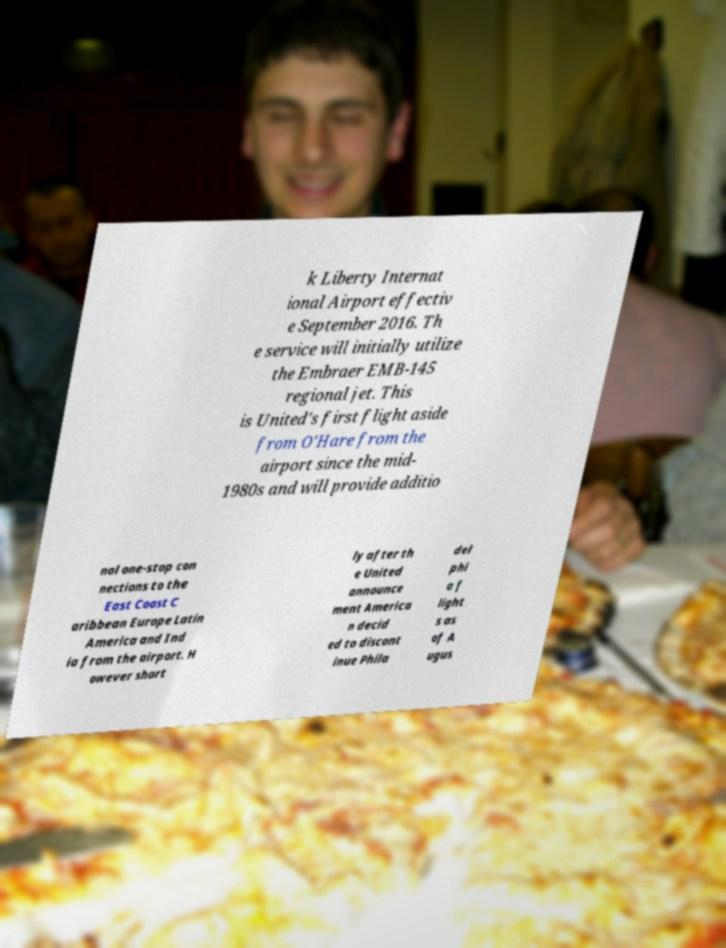Could you extract and type out the text from this image? k Liberty Internat ional Airport effectiv e September 2016. Th e service will initially utilize the Embraer EMB-145 regional jet. This is United's first flight aside from O'Hare from the airport since the mid- 1980s and will provide additio nal one-stop con nections to the East Coast C aribbean Europe Latin America and Ind ia from the airport. H owever short ly after th e United announce ment America n decid ed to discont inue Phila del phi a f light s as of A ugus 